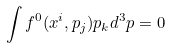<formula> <loc_0><loc_0><loc_500><loc_500>\int f ^ { 0 } ( x ^ { i } , p _ { j } ) p _ { k } d ^ { 3 } p = 0</formula> 